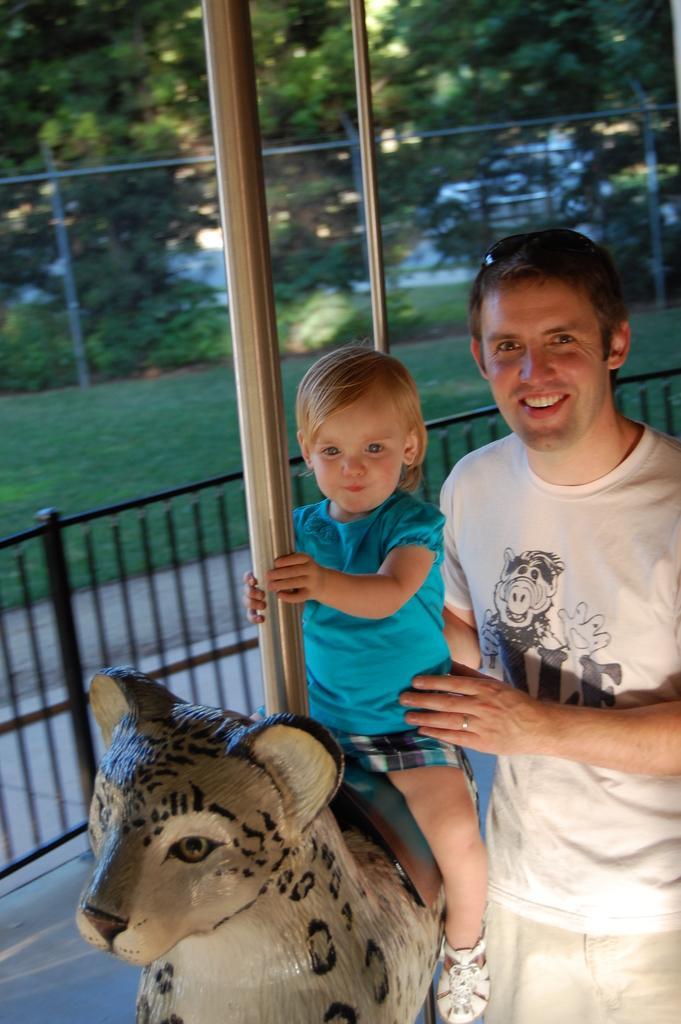Please provide a concise description of this image. In this image we can see a child sitting on a toy animal. Also there is a steel rod. Near to the child there is a person standing. In the back there is railing. In the background there are trees. On the ground there is grass. 